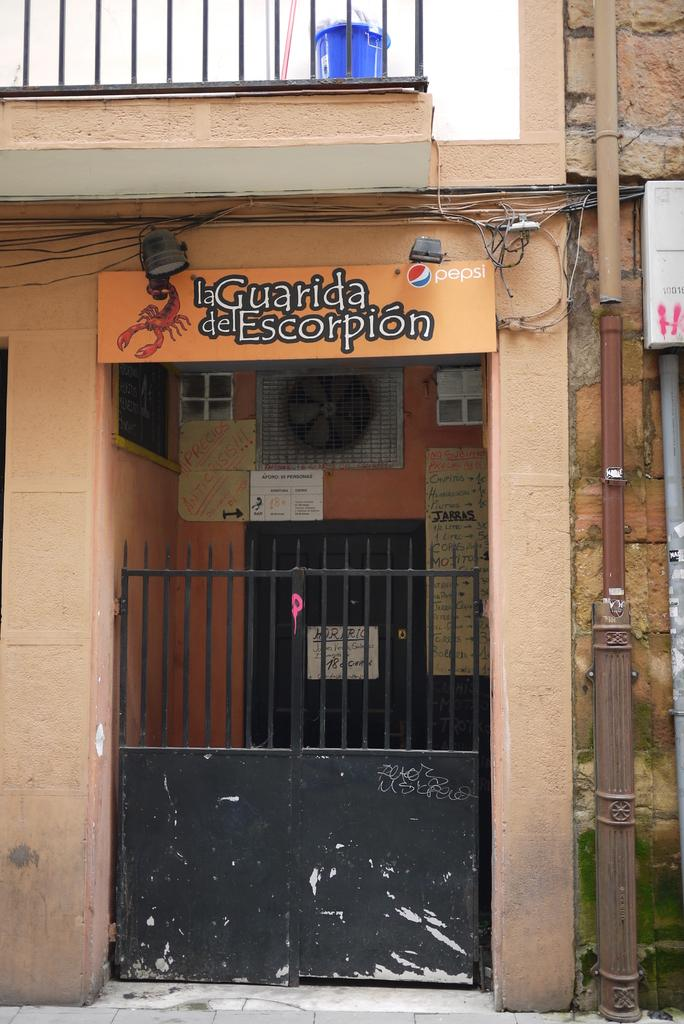What type of structure is present in the image? There is a house in the image. What can be seen on the house? There are cables and pipes on the house. What type of material is visible in the image? Metal rods are visible in the image. What type of dinner is being served in the image? There is no dinner present in the image; it only features a house with cables, pipes, and metal rods. 